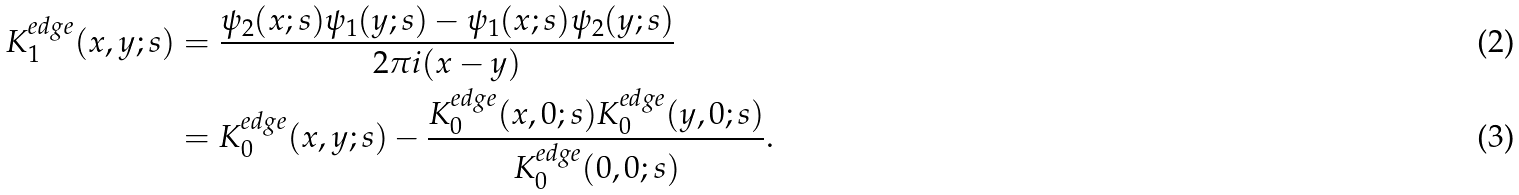Convert formula to latex. <formula><loc_0><loc_0><loc_500><loc_500>K _ { 1 } ^ { e d g e } ( x , y ; s ) & = \frac { \psi _ { 2 } ( x ; s ) \psi _ { 1 } ( y ; s ) - \psi _ { 1 } ( x ; s ) \psi _ { 2 } ( y ; s ) } { 2 \pi i ( x - y ) } \\ & = K _ { 0 } ^ { e d g e } ( x , y ; s ) - \frac { K _ { 0 } ^ { e d g e } ( x , 0 ; s ) K _ { 0 } ^ { e d g e } ( y , 0 ; s ) } { K _ { 0 } ^ { e d g e } ( 0 , 0 ; s ) } .</formula> 